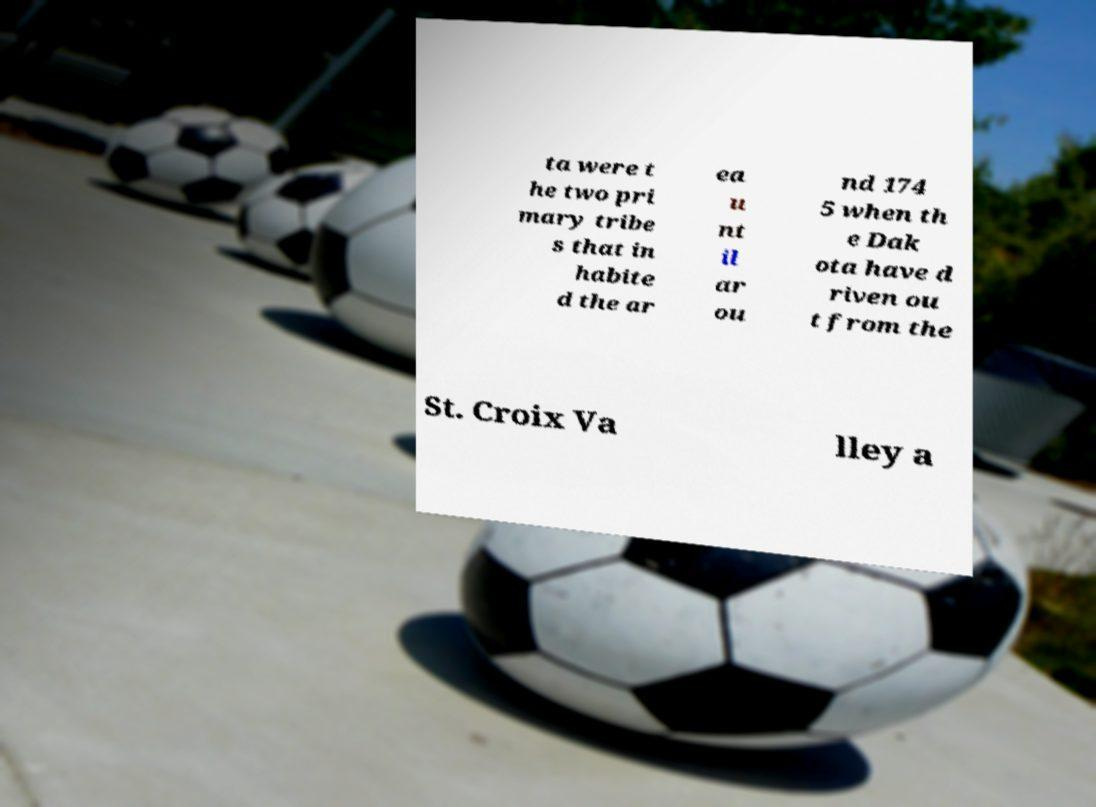Please read and relay the text visible in this image. What does it say? ta were t he two pri mary tribe s that in habite d the ar ea u nt il ar ou nd 174 5 when th e Dak ota have d riven ou t from the St. Croix Va lley a 